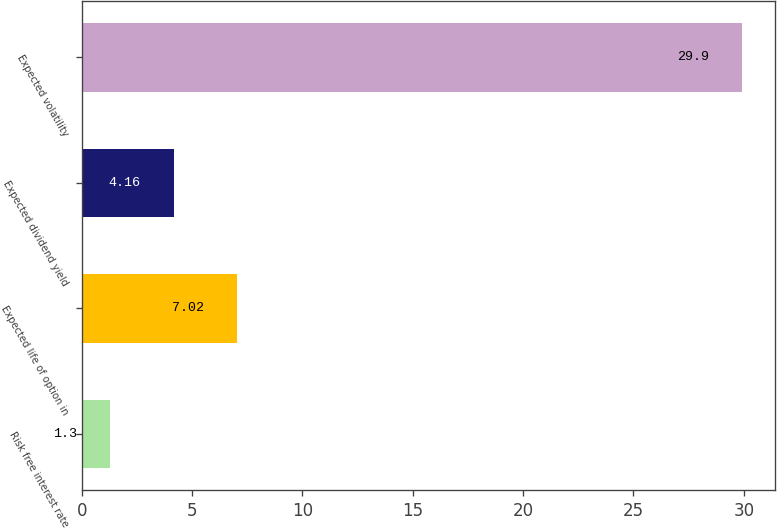Convert chart to OTSL. <chart><loc_0><loc_0><loc_500><loc_500><bar_chart><fcel>Risk free interest rate<fcel>Expected life of option in<fcel>Expected dividend yield<fcel>Expected volatility<nl><fcel>1.3<fcel>7.02<fcel>4.16<fcel>29.9<nl></chart> 